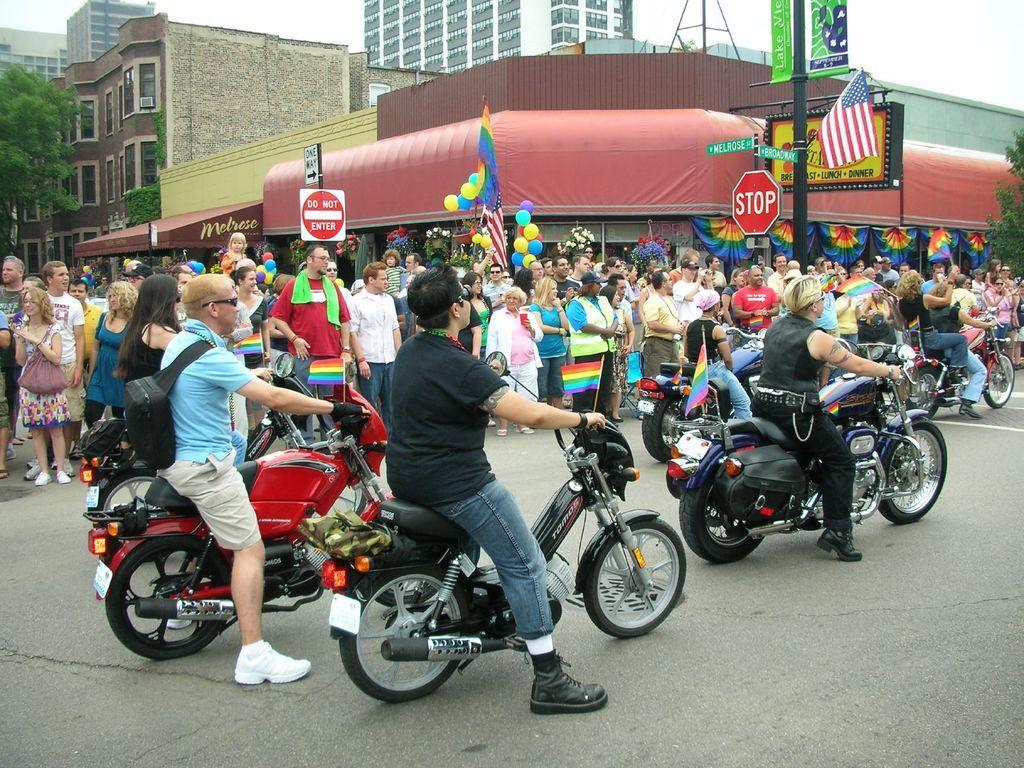In one or two sentences, can you explain what this image depicts? Group of people standing. These persons sitting on the bike and riding bike. This is road. We can see buildings,tree,pole,flag,boards,balloons. 